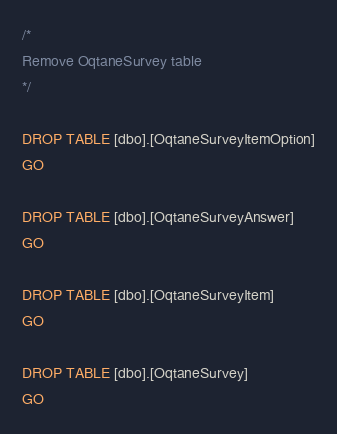<code> <loc_0><loc_0><loc_500><loc_500><_SQL_>/*  
Remove OqtaneSurvey table
*/

DROP TABLE [dbo].[OqtaneSurveyItemOption]
GO

DROP TABLE [dbo].[OqtaneSurveyAnswer]
GO

DROP TABLE [dbo].[OqtaneSurveyItem]
GO

DROP TABLE [dbo].[OqtaneSurvey]
GO</code> 